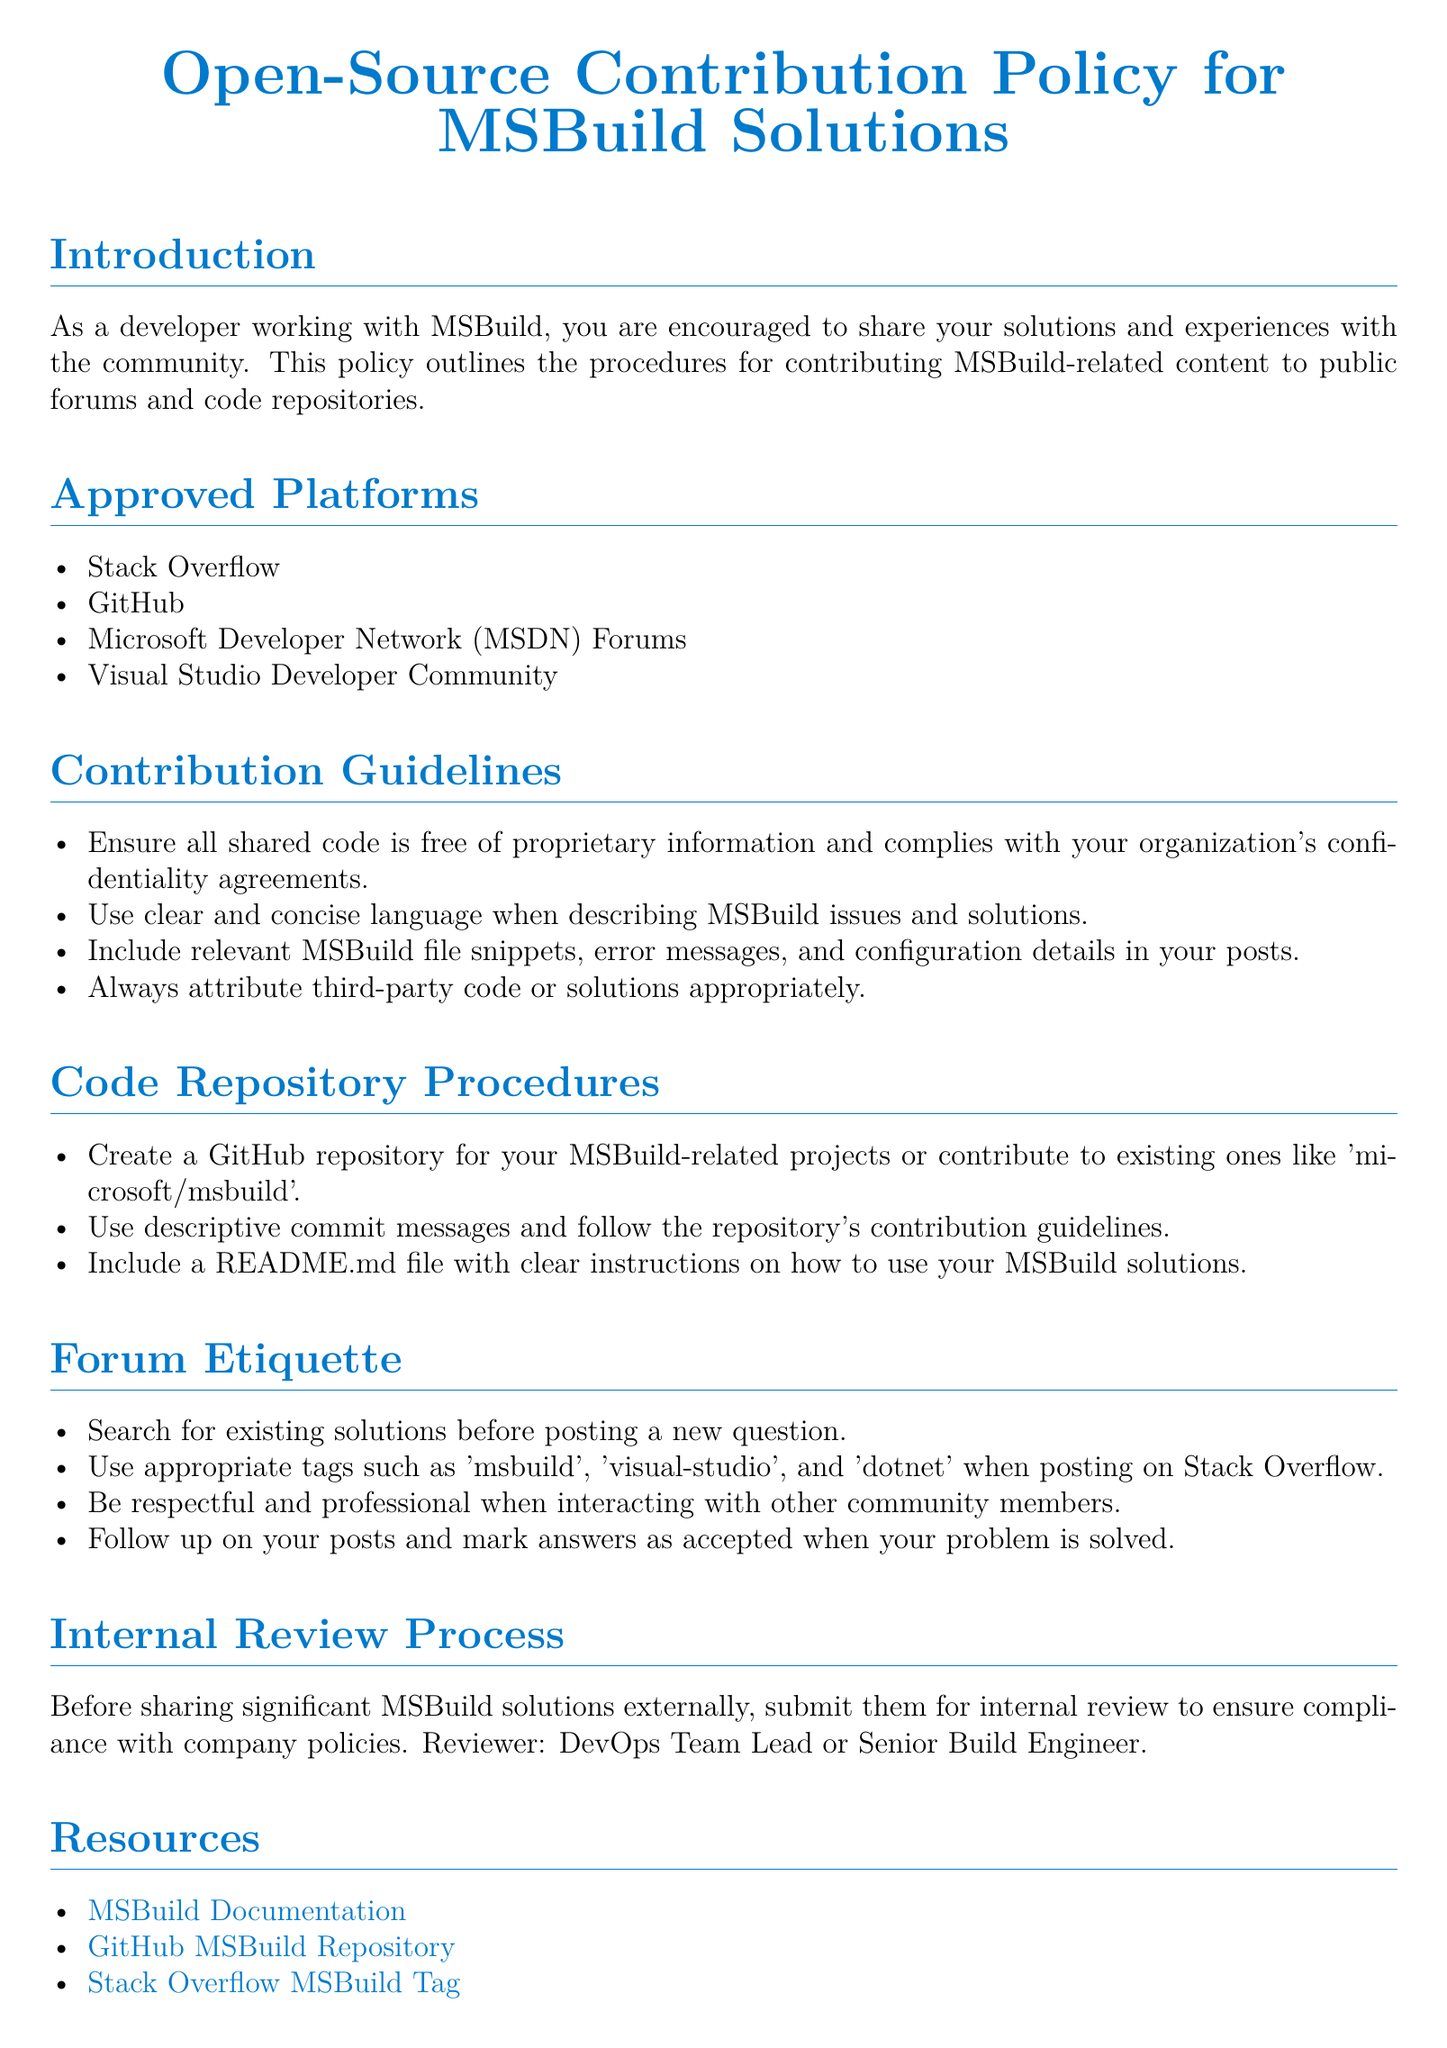What are the approved platforms for sharing MSBuild solutions? The document lists approved platforms where developers can share MSBuild solutions.
Answer: Stack Overflow, GitHub, Microsoft Developer Network, Visual Studio Developer Community Who should review significant MSBuild solutions before sharing externally? The internal review process outlines who is responsible for reviewing significant contributions.
Answer: DevOps Team Lead or Senior Build Engineer What type of content is encouraged for sharing according to the policy? The policy encourages sharing specific content by developers working with MSBuild.
Answer: Solutions and experiences What should be included in a README.md file for MSBuild projects? The document specifies guidelines for contributions, including the necessary components of a project repository.
Answer: Clear instructions on how to use What is one proper tag to use when posting on Stack Overflow? The document emphasizes the importance of using appropriate tags for posting questions in forums.
Answer: msbuild What should developers ensure regarding their shared code? The contribution guidelines in the document indicate what developers need to verify about the code they share.
Answer: Free of proprietary information What is the procedure for a developer before posting a question on a forum? The forum etiquette section mentions the actions a developer should take before posting queries.
Answer: Search for existing solutions What color is used for links in the document? The document specifies the color setup for links which can be helpful for users.
Answer: msbuild blue 